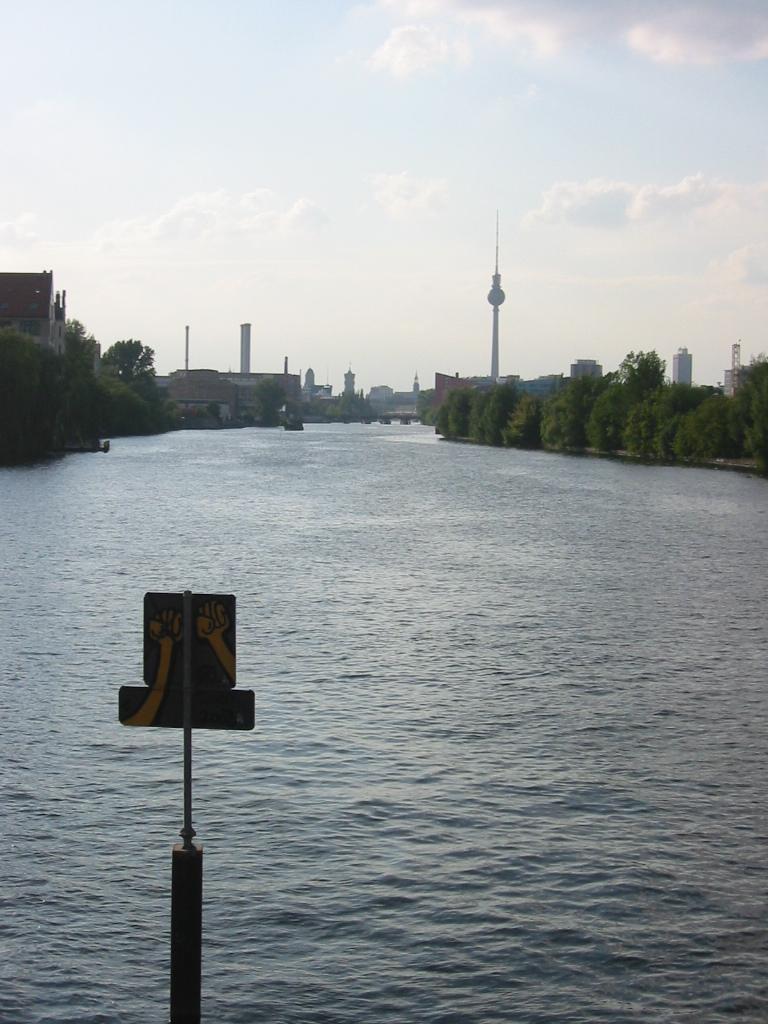Can you describe this image briefly? In this image we can see a board to the pole, we can see water, trees, tower buildings and the sky with clouds in the background. 